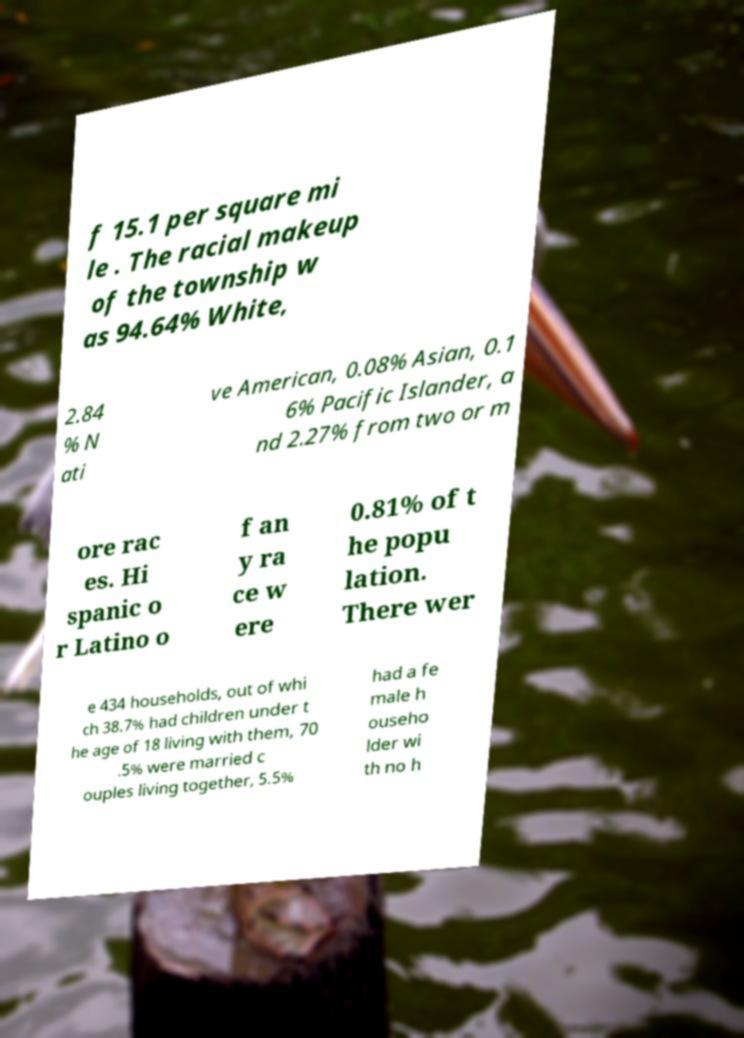Could you extract and type out the text from this image? f 15.1 per square mi le . The racial makeup of the township w as 94.64% White, 2.84 % N ati ve American, 0.08% Asian, 0.1 6% Pacific Islander, a nd 2.27% from two or m ore rac es. Hi spanic o r Latino o f an y ra ce w ere 0.81% of t he popu lation. There wer e 434 households, out of whi ch 38.7% had children under t he age of 18 living with them, 70 .5% were married c ouples living together, 5.5% had a fe male h ouseho lder wi th no h 